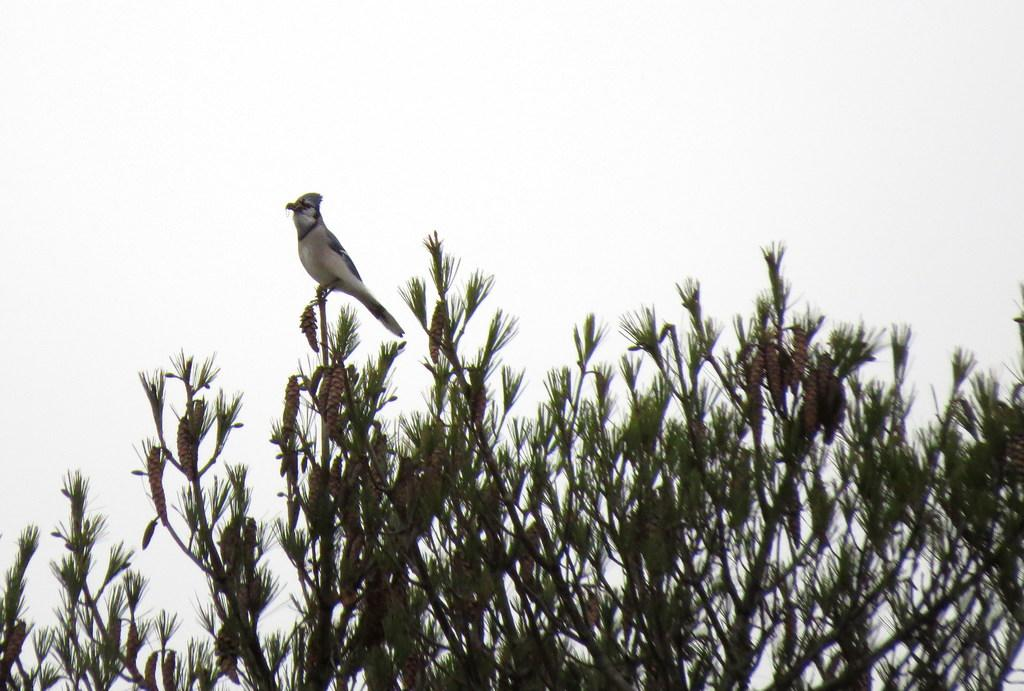What is located at the bottom of the picture? There is a tree at the bottom of the picture. What can be seen on the tree? A bird in white color is on the tree. What is visible in the background of the image? The sky is visible in the background of the image. Can you tell me how many combs are being used by the giants in the image? There are no giants or combs present in the image. What type of guide is helping the bird in the image? There is no guide present in the image; the bird is simply perched on the tree. 